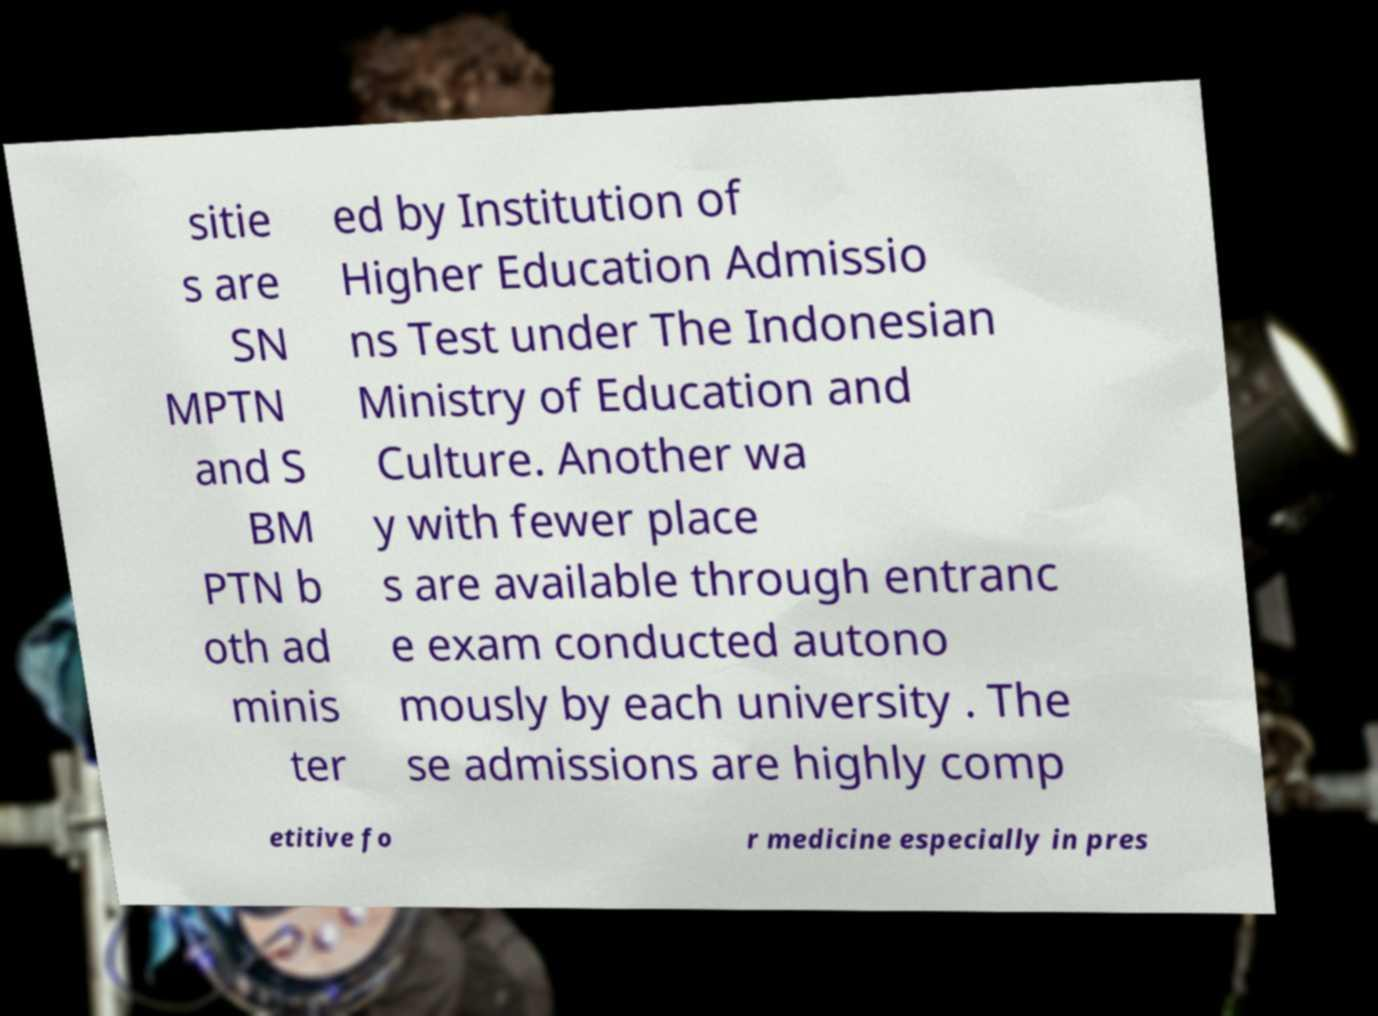For documentation purposes, I need the text within this image transcribed. Could you provide that? sitie s are SN MPTN and S BM PTN b oth ad minis ter ed by Institution of Higher Education Admissio ns Test under The Indonesian Ministry of Education and Culture. Another wa y with fewer place s are available through entranc e exam conducted autono mously by each university . The se admissions are highly comp etitive fo r medicine especially in pres 